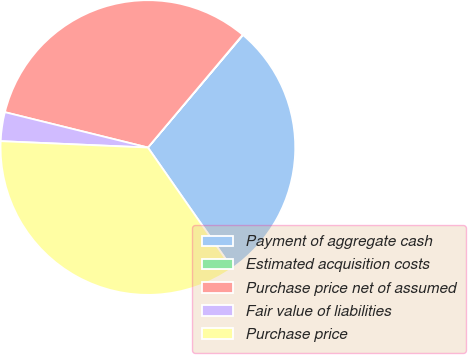Convert chart. <chart><loc_0><loc_0><loc_500><loc_500><pie_chart><fcel>Payment of aggregate cash<fcel>Estimated acquisition costs<fcel>Purchase price net of assumed<fcel>Fair value of liabilities<fcel>Purchase price<nl><fcel>29.14%<fcel>0.04%<fcel>32.27%<fcel>3.17%<fcel>35.39%<nl></chart> 